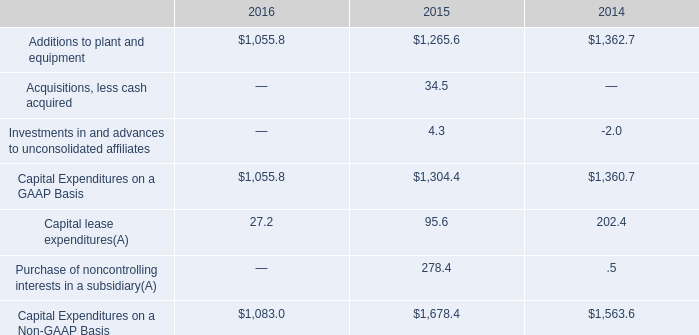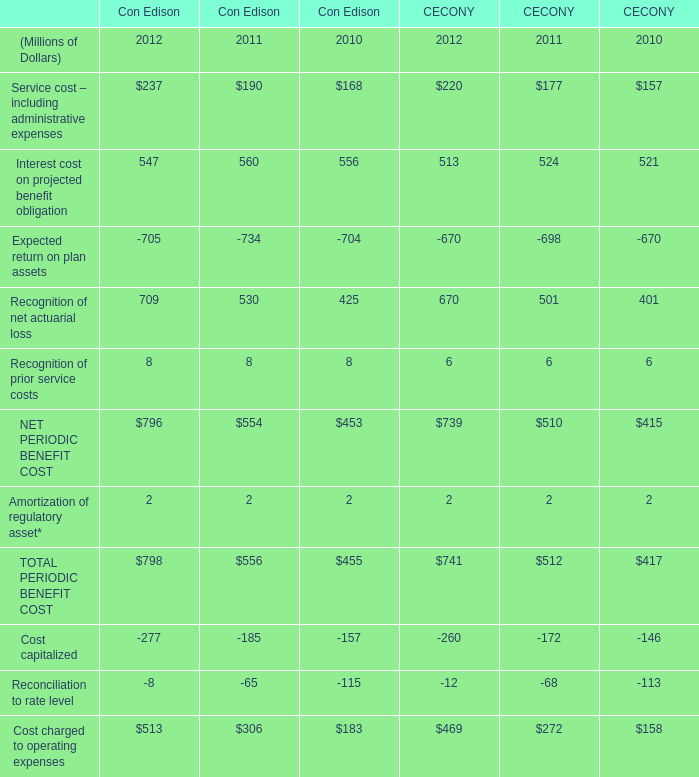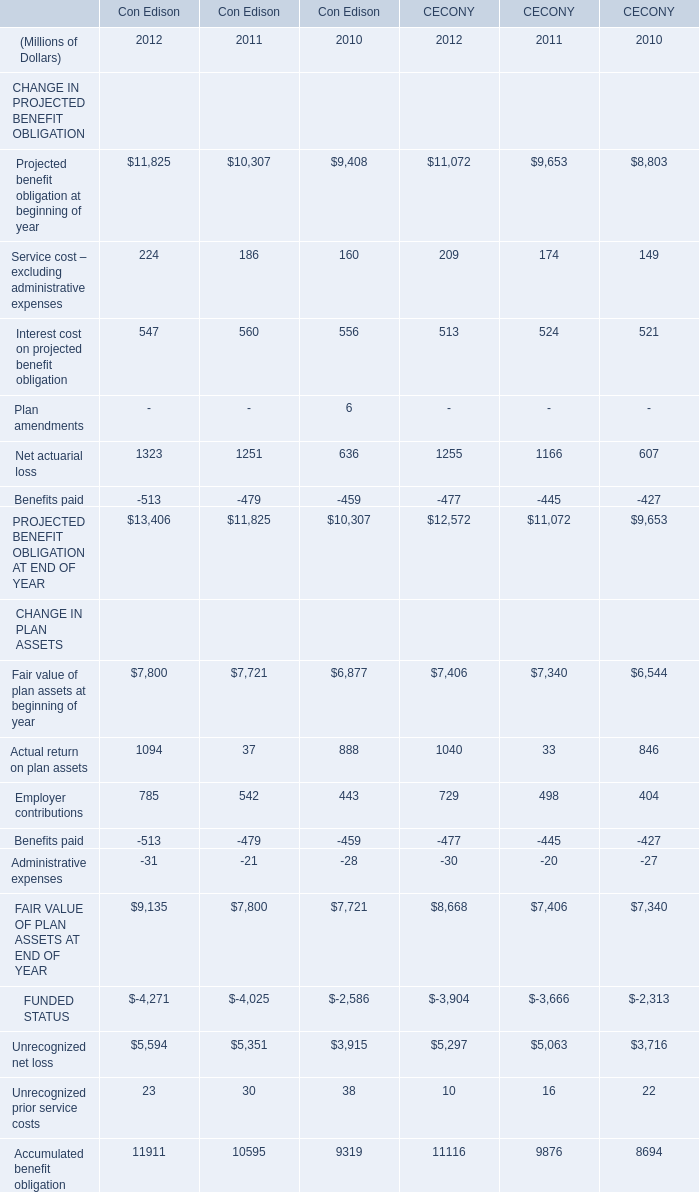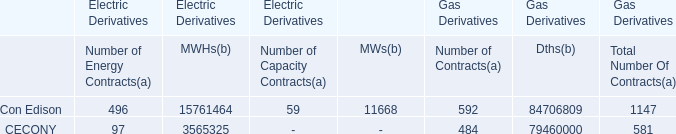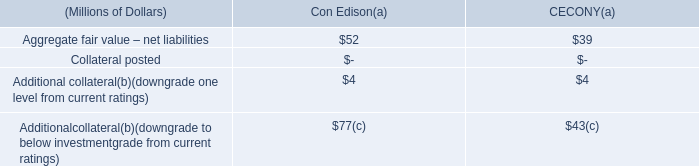In the year with the most Projected benefit obligation at beginning of year, what is the growth rate of Service cost – excluding administrative expenses for Con Edison? 
Computations: ((224 - 186) / 224)
Answer: 0.16964. 